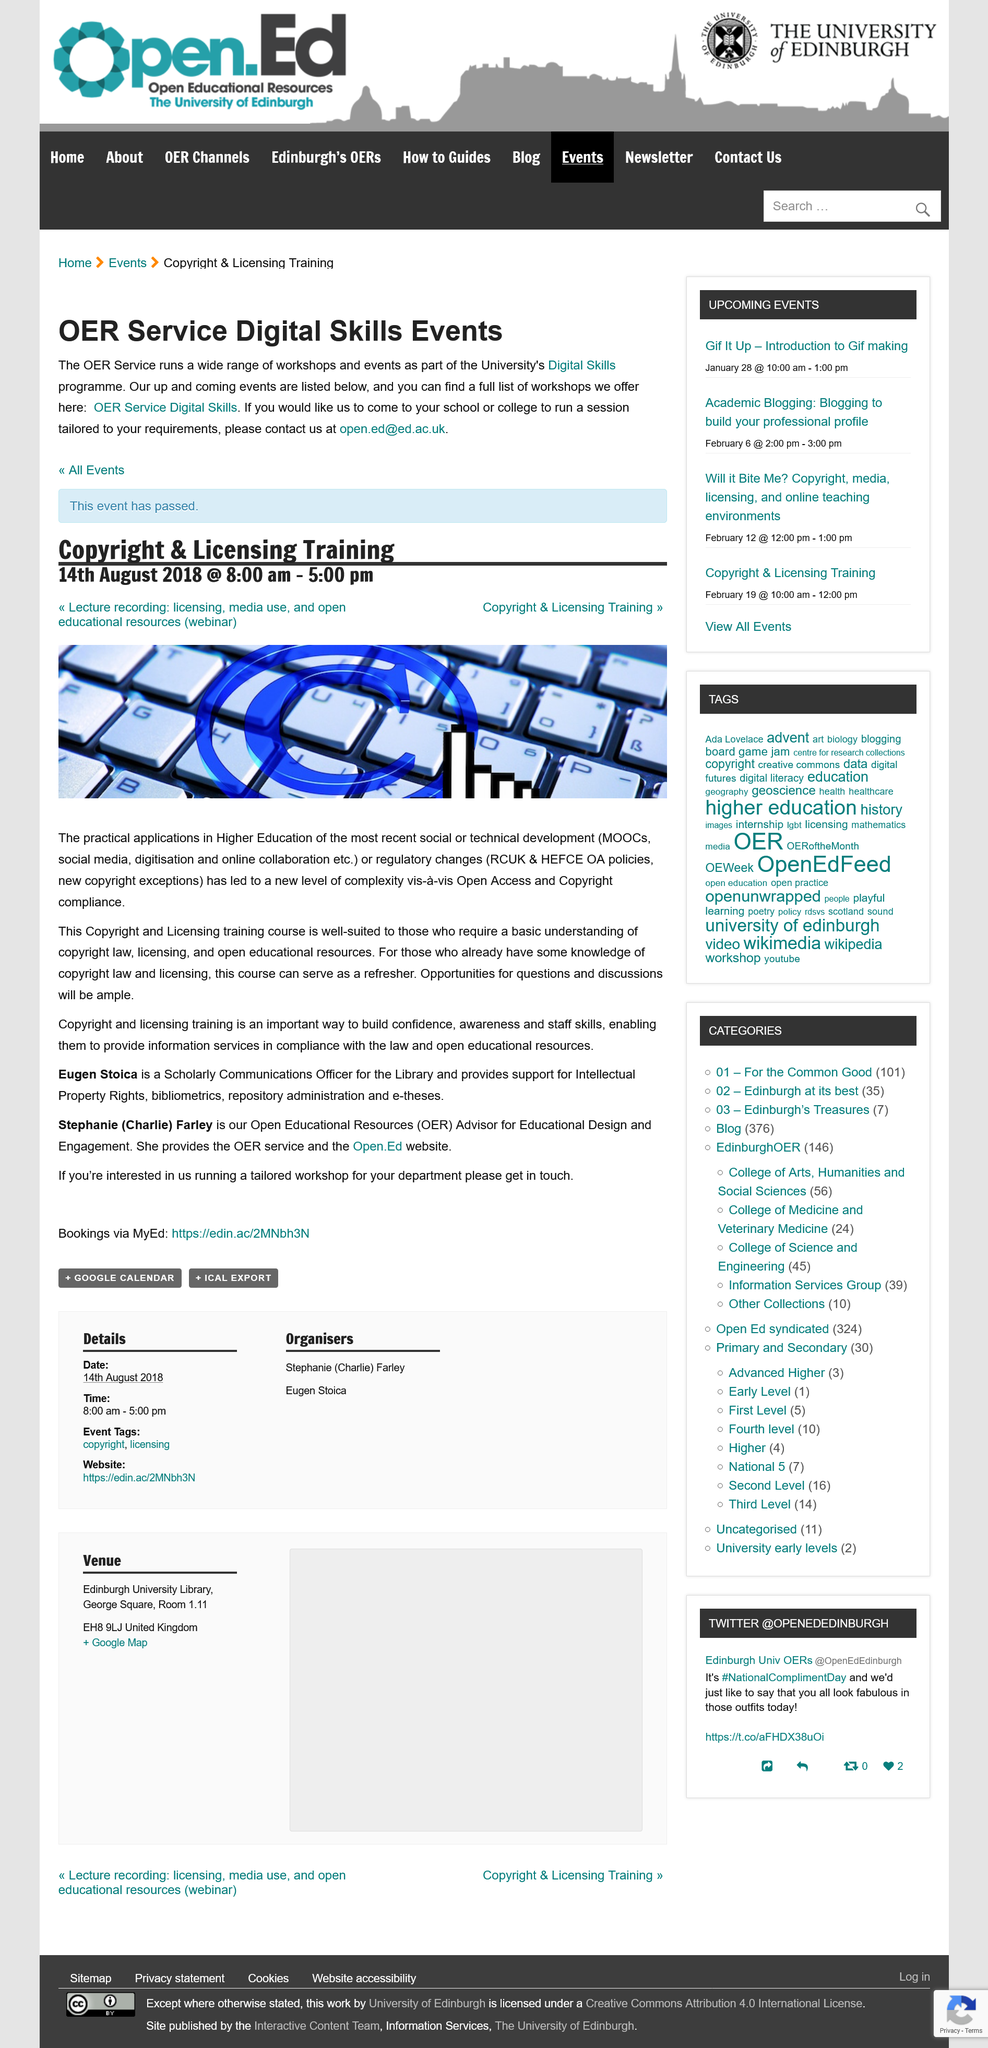Mention a couple of crucial points in this snapshot. The Copyright and Licensing training finished at 5:00pm. The Copyright and Licensing training took place on August 14th, 2018. The training course covers the subject of copyright and licensing. The two named individuals mentioned in the passage are Eugen Stoica and Stephanie (Charlie) Farley. If you wish to make a booking, please visit the MyEd website: <https://edin.ac/2MNbh3N>. 